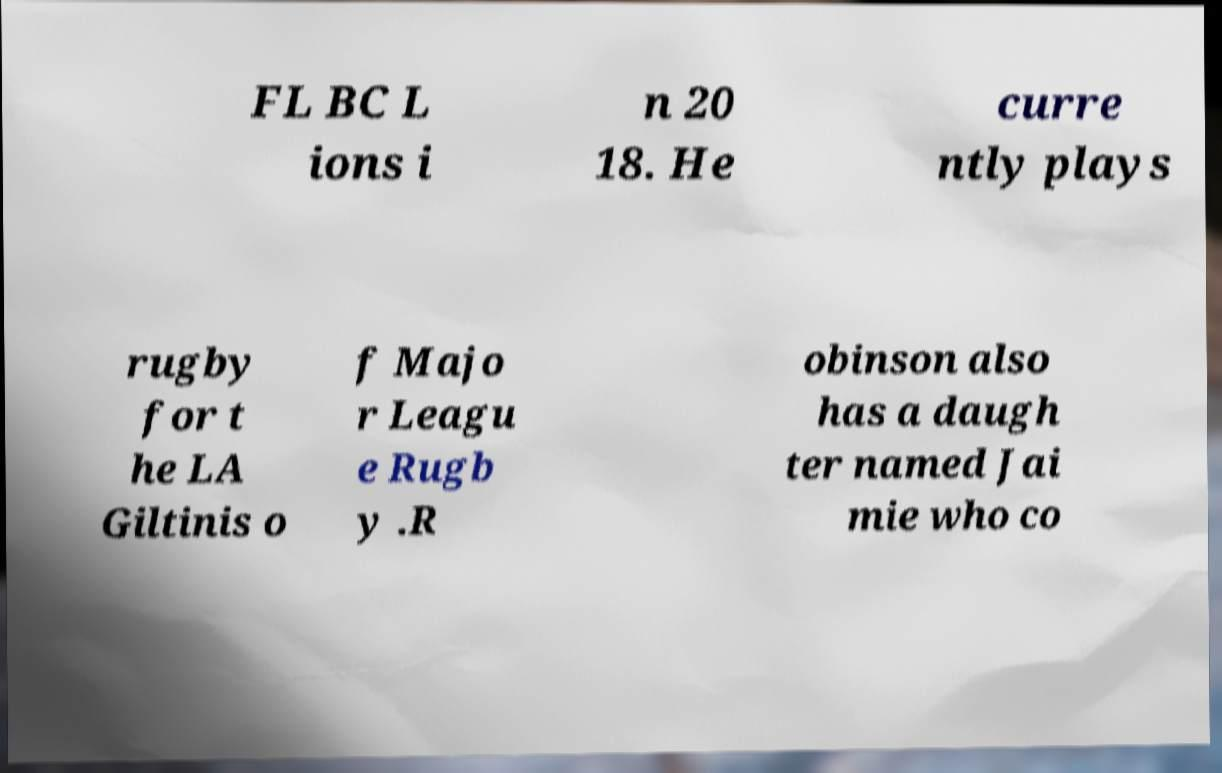Please identify and transcribe the text found in this image. FL BC L ions i n 20 18. He curre ntly plays rugby for t he LA Giltinis o f Majo r Leagu e Rugb y .R obinson also has a daugh ter named Jai mie who co 